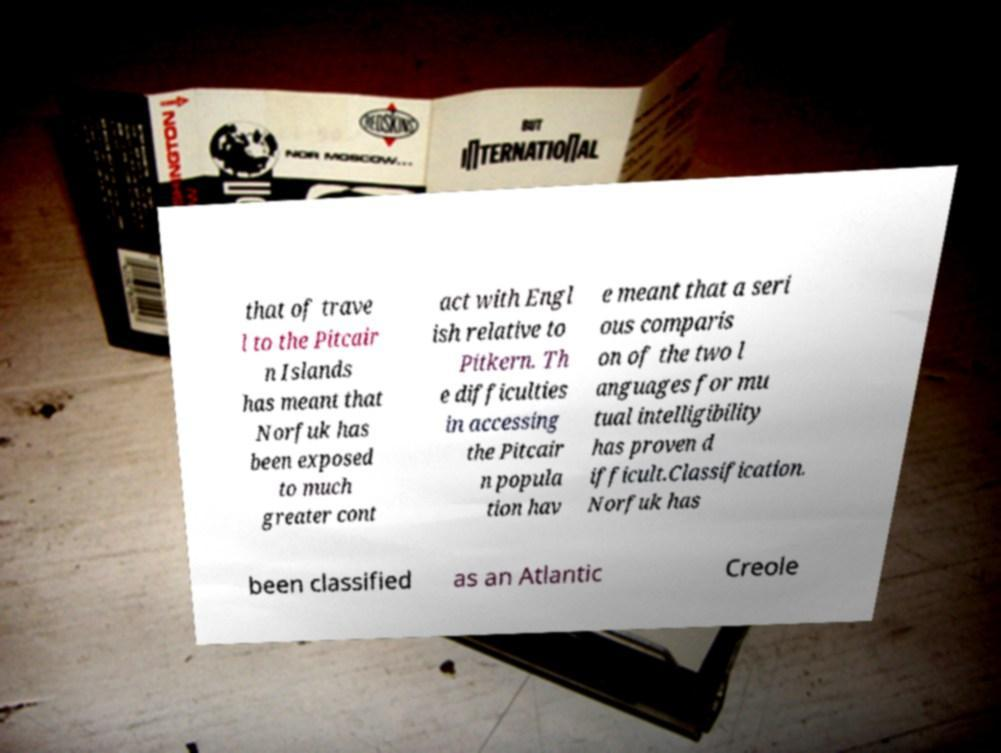Please identify and transcribe the text found in this image. that of trave l to the Pitcair n Islands has meant that Norfuk has been exposed to much greater cont act with Engl ish relative to Pitkern. Th e difficulties in accessing the Pitcair n popula tion hav e meant that a seri ous comparis on of the two l anguages for mu tual intelligibility has proven d ifficult.Classification. Norfuk has been classified as an Atlantic Creole 